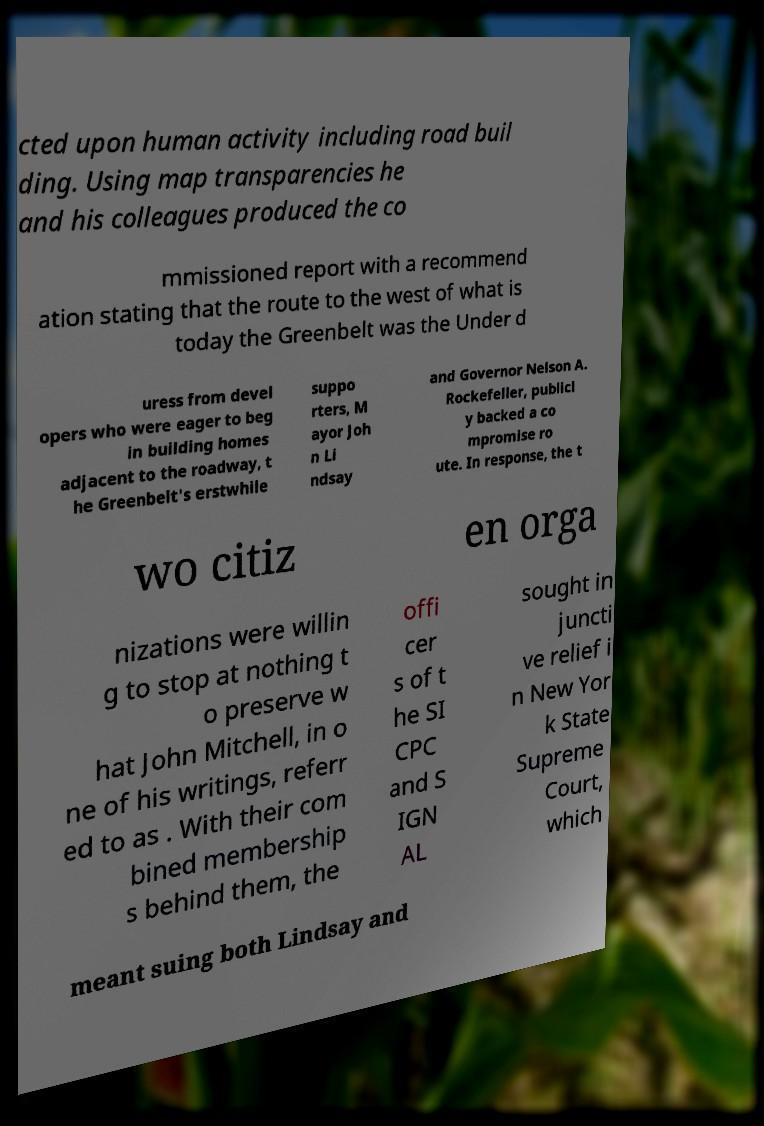Please read and relay the text visible in this image. What does it say? cted upon human activity including road buil ding. Using map transparencies he and his colleagues produced the co mmissioned report with a recommend ation stating that the route to the west of what is today the Greenbelt was the Under d uress from devel opers who were eager to beg in building homes adjacent to the roadway, t he Greenbelt's erstwhile suppo rters, M ayor Joh n Li ndsay and Governor Nelson A. Rockefeller, publicl y backed a co mpromise ro ute. In response, the t wo citiz en orga nizations were willin g to stop at nothing t o preserve w hat John Mitchell, in o ne of his writings, referr ed to as . With their com bined membership s behind them, the offi cer s of t he SI CPC and S IGN AL sought in juncti ve relief i n New Yor k State Supreme Court, which meant suing both Lindsay and 